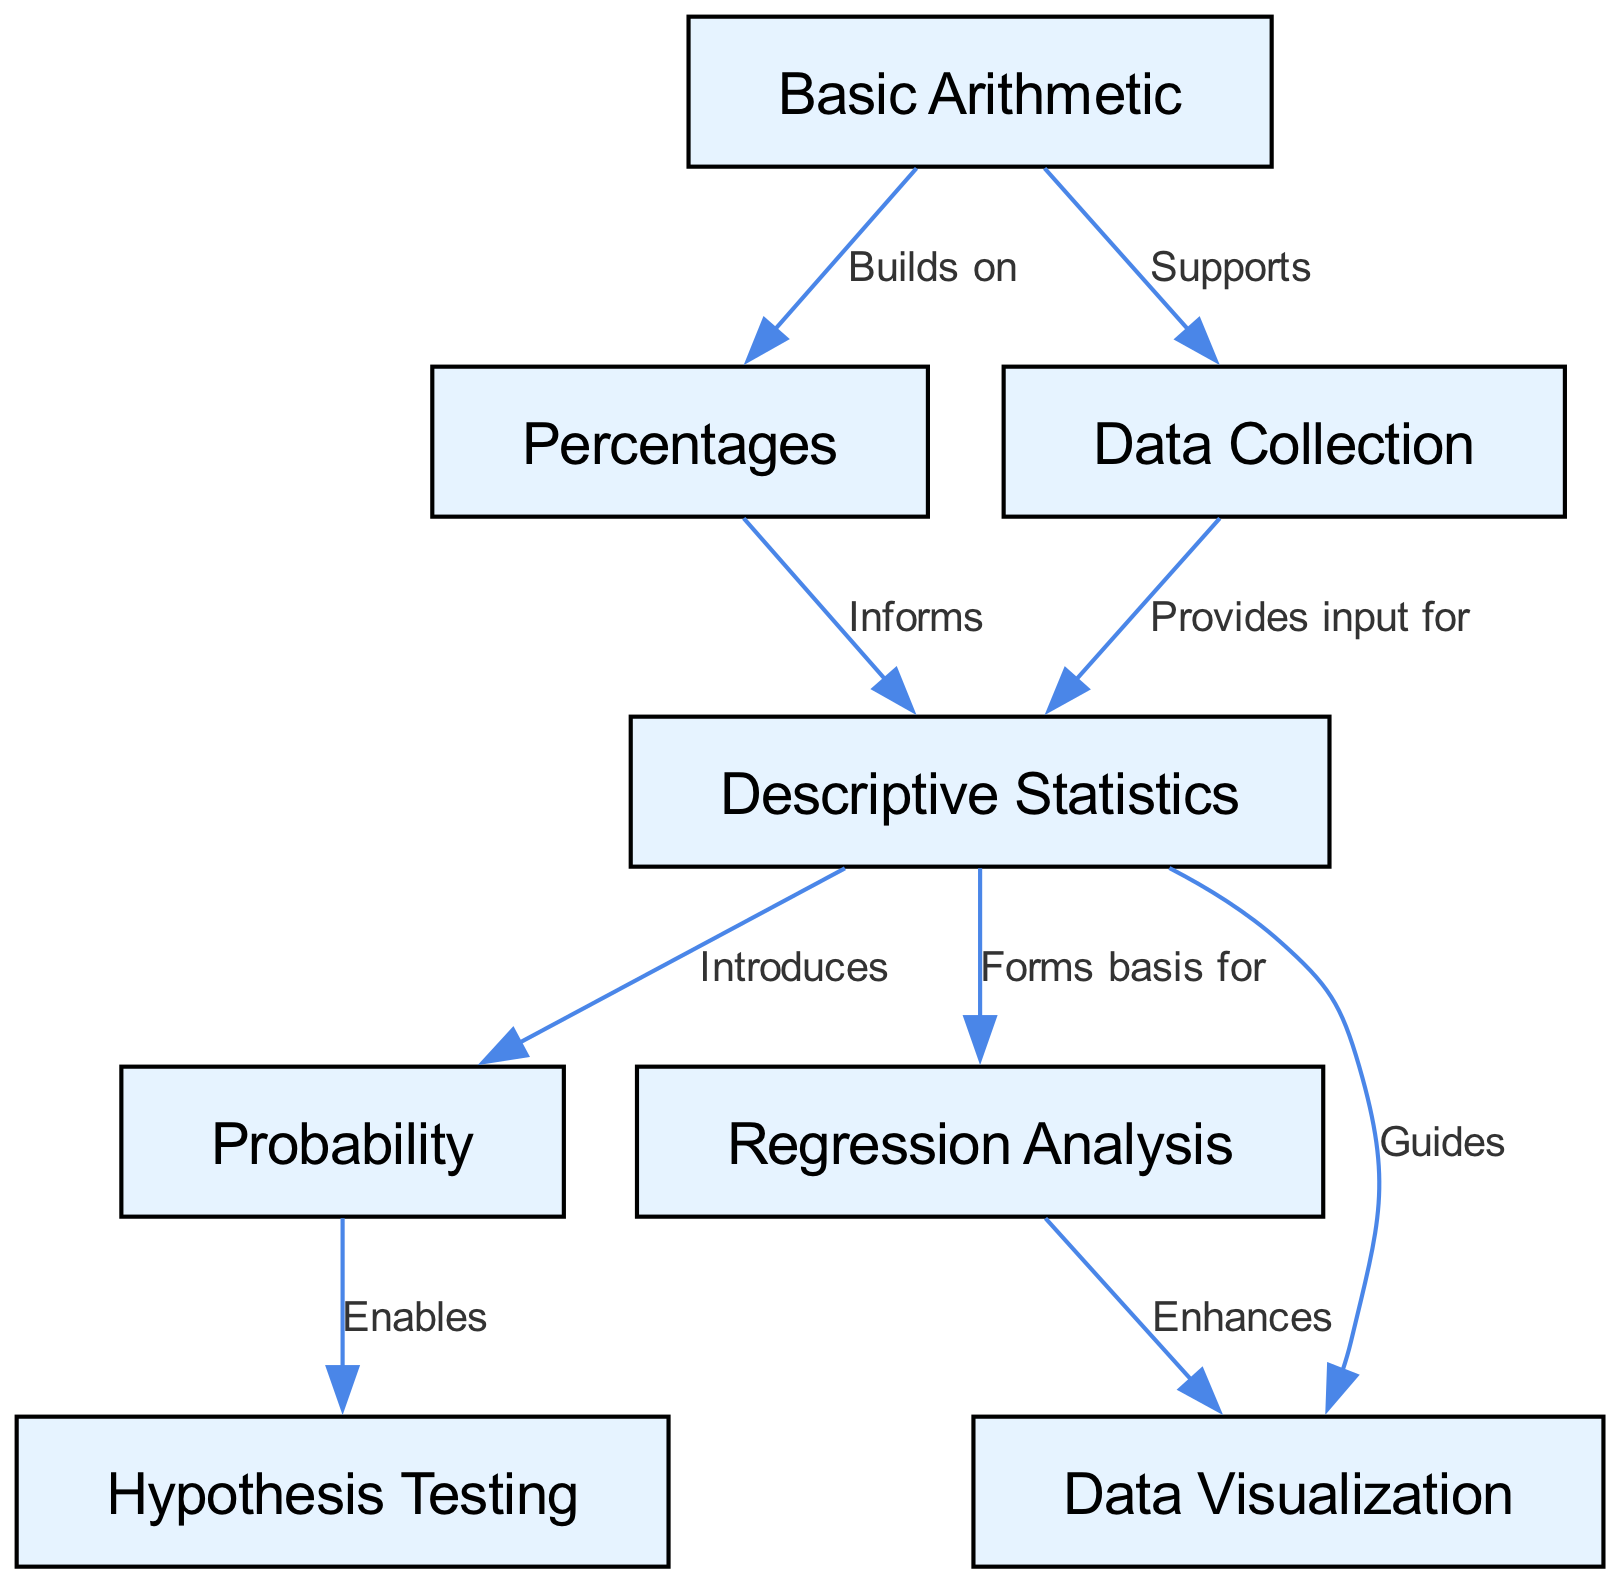What is the total number of nodes in the diagram? The diagram lists eight distinct concepts as nodes: Basic Arithmetic, Percentages, Data Collection, Descriptive Statistics, Probability, Hypothesis Testing, Regression Analysis, and Data Visualization. Counting these reveals the total count as eight nodes.
Answer: 8 Which concept does Basic Arithmetic support? In the diagram, Basic Arithmetic connects to Data Collection with an arrow labeled "Supports". This indicates that Basic Arithmetic provides foundational support for the Data Collection process.
Answer: Data Collection What type of relationship exists between Descriptive Statistics and Regression Analysis? The diagram establishes a directional relationship where Descriptive Statistics "Forms basis for" Regression Analysis. This indicates that Descriptive Statistics provides foundational knowledge necessary for understanding Regression Analysis.
Answer: Forms basis for How many edges are connected to Descriptive Statistics? By examining the diagram, we can see that Descriptive Statistics has four connecting edges: it connects to Probability, Regression Analysis, Data Visualization, and receives input from Data Collection. Counting these gives us a total of four edges connected to Descriptive Statistics.
Answer: 4 Which statistical concept directly enables Hypothesis Testing? The diagram indicates that Probability is the direct precursor that enables Hypothesis Testing, as evident from the directed edge labeled "Enables" going from Probability to Hypothesis Testing.
Answer: Probability What informs Descriptive Statistics? The diagram shows that Percentages informs Descriptive Statistics through a directed edge labeled "Informs". This indicates that understanding Percentages contributes to the knowledge of Descriptive Statistics.
Answer: Percentages What concept is guided by Descriptive Statistics in terms of visualization? Following the directional arrow mapped out in the diagram, it's clear that Data Visualization is guided by Descriptive Statistics, as indicated by the connection labeled "Guides".
Answer: Data Visualization Which two concepts enhance the understanding of data visualization, directly or indirectly? By analyzing the connections in the diagram, Data Visualization is enhanced by both Regression Analysis and guided by Descriptive Statistics, thus creating an indirect link. The direct enhancement comes solely from Regression Analysis.
Answer: Regression Analysis What relationship exists between Descriptive Statistics and Probability? The diagram depicts a directional relationship where Descriptive Statistics "Introduces" Probability, indicating that Descriptive Statistics serves as an introductory concept to the understanding of Probability.
Answer: Introduces 